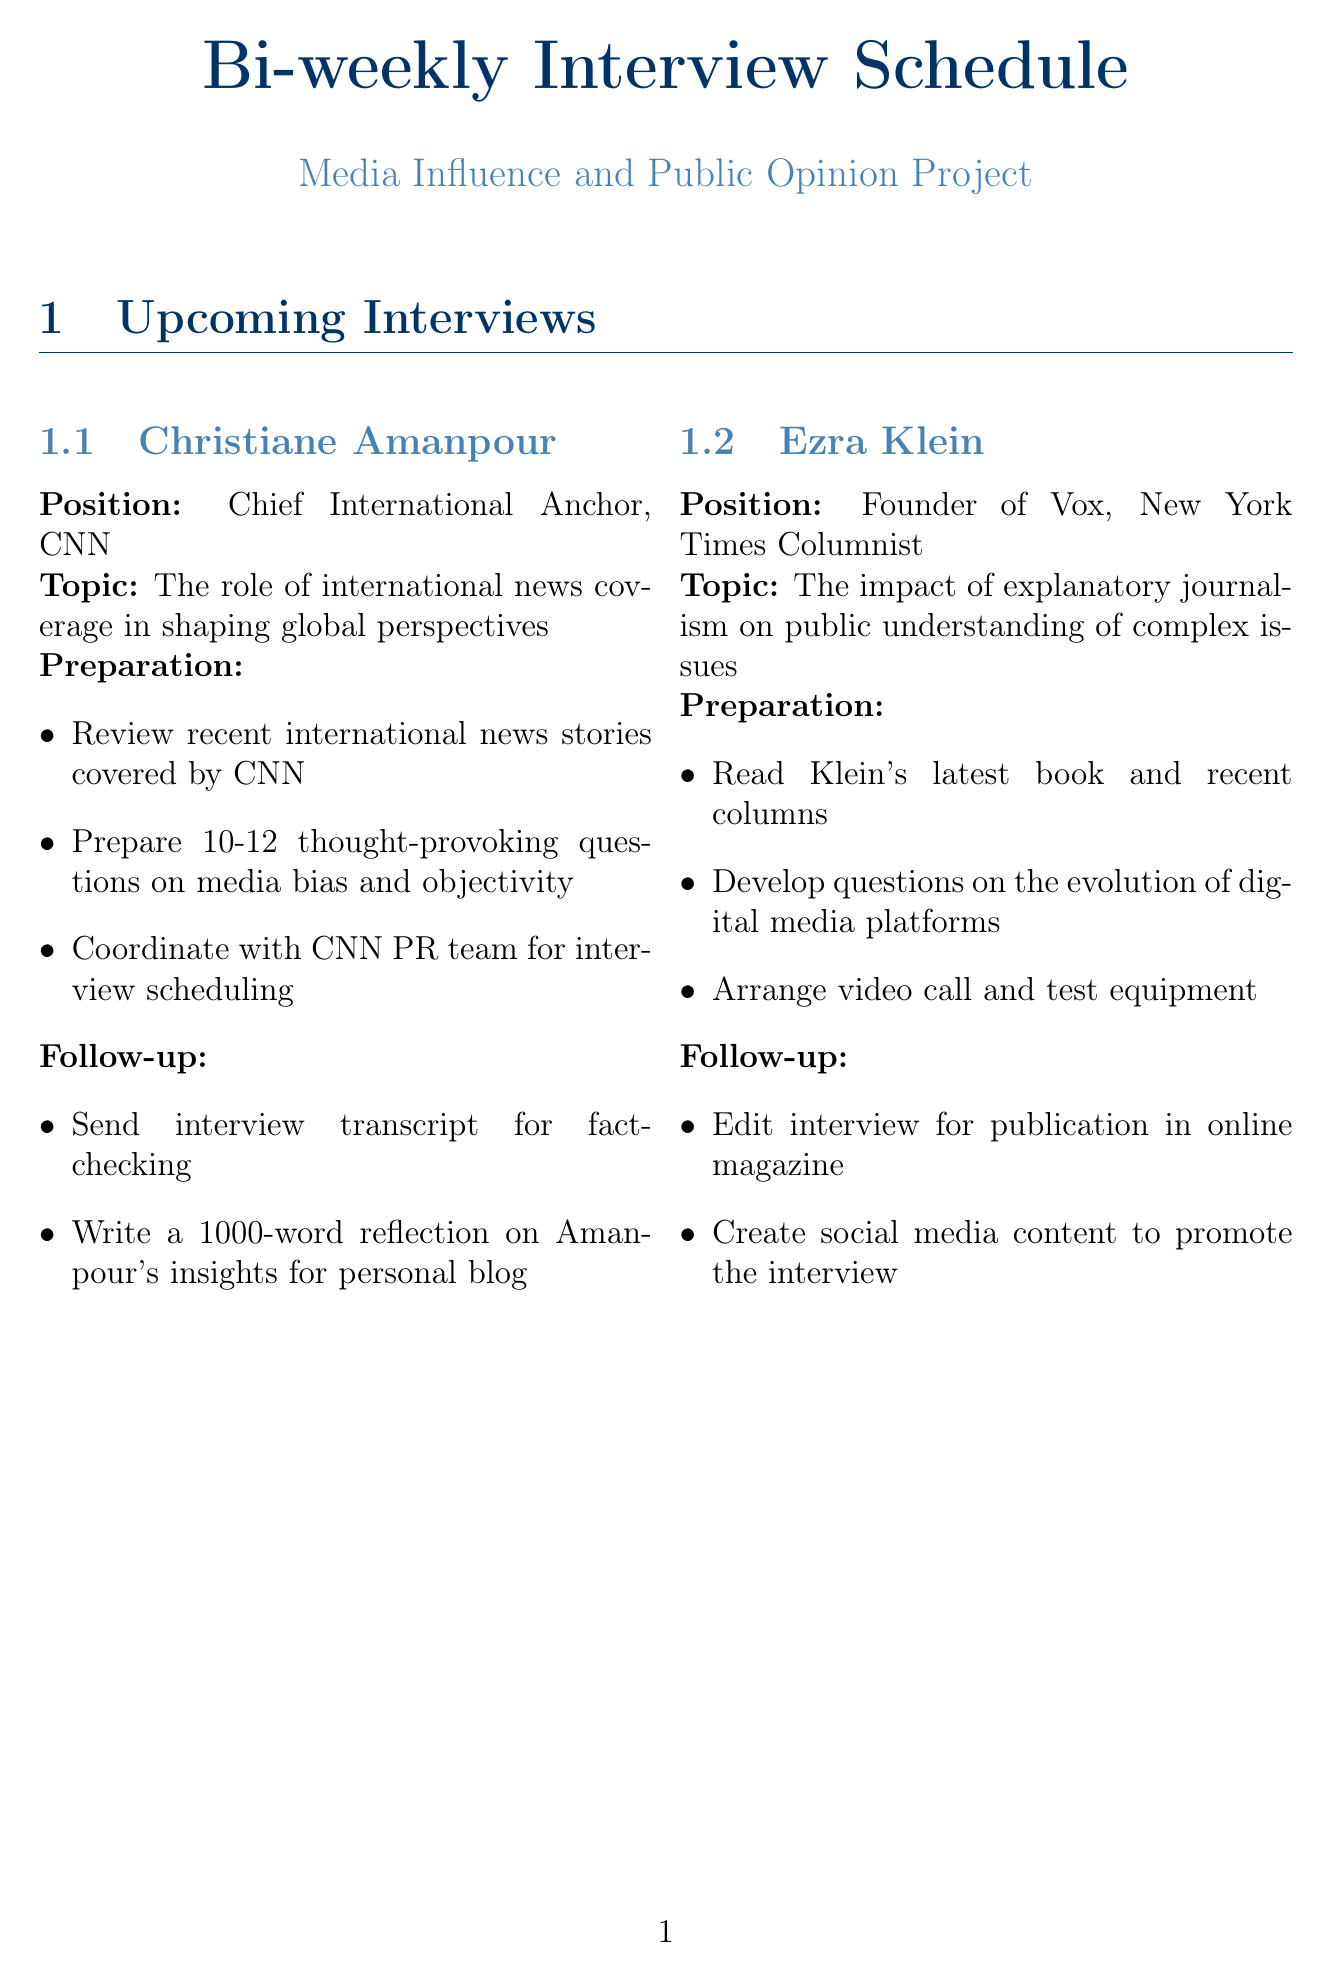What is the position of Christiane Amanpour? Christiane Amanpour is identified in the document with her specific position at CNN.
Answer: Chief International Anchor, CNN What is the topic of the interview with Ezra Klein? The document outlines the specific interview topics associated with each interviewee.
Answer: The impact of explanatory journalism on public understanding of complex issues Which equipment is listed for clear audio in remote video interviews? The document includes a checklist of the equipment needed for the interviews and their purposes.
Answer: Blue Yeti USB Microphone Who is the interviewee focused on press freedom? The document lists various interviewees and identifies their focus areas.
Answer: Maria Ressa What is one of the follow-up tasks for Zeynep Tufekci? The document details the follow-up tasks assigned to each interviewee after their respective interviews.
Answer: Write a summary of key points for newsletter subscribers How many thought-provoking questions should be prepared for Christiane Amanpour? The preparation section for each interviewee stipulates how many questions need to be prepared.
Answer: 10-12 What type of project does Maria Ressa want to explore collaboration on? The document indicates potential collaborative projects for each interviewee in their follow-up tasks.
Answer: Disinformation research project Which resource provides global trends in media consumption and trust? The document contains a list of resources along with their purposes and benefits.
Answer: Reuters Institute Digital News Report 